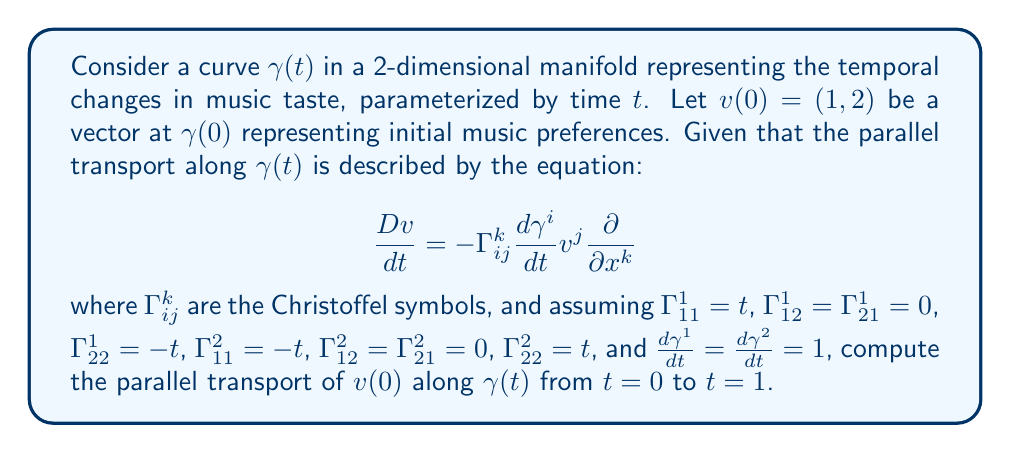Teach me how to tackle this problem. To solve this problem, we need to follow these steps:

1) The parallel transport equation for each component of the vector $v(t) = (v^1(t), v^2(t))$ is:

   $$\frac{dv^k}{dt} = -\Gamma_{ij}^k \frac{d\gamma^i}{dt} v^j$$

2) For $k=1$:
   $$\frac{dv^1}{dt} = -(\Gamma_{11}^1 \frac{d\gamma^1}{dt} v^1 + \Gamma_{12}^1 \frac{d\gamma^1}{dt} v^2 + \Gamma_{21}^1 \frac{d\gamma^2}{dt} v^1 + \Gamma_{22}^1 \frac{d\gamma^2}{dt} v^2)$$
   
   Substituting the given values:
   $$\frac{dv^1}{dt} = -(t \cdot 1 \cdot v^1 + 0 + 0 + (-t) \cdot 1 \cdot v^2) = -tv^1 + tv^2$$

3) Similarly, for $k=2$:
   $$\frac{dv^2}{dt} = -(\Gamma_{11}^2 \frac{d\gamma^1}{dt} v^1 + \Gamma_{12}^2 \frac{d\gamma^1}{dt} v^2 + \Gamma_{21}^2 \frac{d\gamma^2}{dt} v^1 + \Gamma_{22}^2 \frac{d\gamma^2}{dt} v^2)$$
   
   Substituting the given values:
   $$\frac{dv^2}{dt} = -((-t) \cdot 1 \cdot v^1 + 0 + 0 + t \cdot 1 \cdot v^2) = tv^1 - tv^2$$

4) We now have a system of differential equations:
   $$\begin{cases}
   \frac{dv^1}{dt} = -tv^1 + tv^2 \\
   \frac{dv^2}{dt} = tv^1 - tv^2
   \end{cases}$$

5) This system can be written in matrix form:
   $$\frac{d}{dt}\begin{pmatrix} v^1 \\ v^2 \end{pmatrix} = \begin{pmatrix} -t & t \\ t & -t \end{pmatrix}\begin{pmatrix} v^1 \\ v^2 \end{pmatrix}$$

6) The solution to this system with initial condition $v(0) = (1, 2)$ is:
   $$\begin{pmatrix} v^1(t) \\ v^2(t) \end{pmatrix} = e^{-\frac{t^2}{2}}\begin{pmatrix} \cos t & -\sin t \\ \sin t & \cos t \end{pmatrix}\begin{pmatrix} 1 \\ 2 \end{pmatrix}$$

7) Evaluating at $t=1$:
   $$\begin{pmatrix} v^1(1) \\ v^2(1) \end{pmatrix} = e^{-\frac{1}{2}}\begin{pmatrix} \cos 1 & -\sin 1 \\ \sin 1 & \cos 1 \end{pmatrix}\begin{pmatrix} 1 \\ 2 \end{pmatrix}$$

8) Computing this:
   $$\begin{pmatrix} v^1(1) \\ v^2(1) \end{pmatrix} \approx \begin{pmatrix} 0.8776 \\ 1.9843 \end{pmatrix}$$
Answer: $(0.8776, 1.9843)$ 